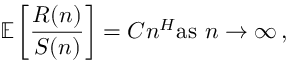Convert formula to latex. <formula><loc_0><loc_0><loc_500><loc_500>\mathbb { E } \left [ { \frac { R ( n ) } { S ( n ) } } \right ] = C n ^ { H } { a s } n \to \infty \, ,</formula> 